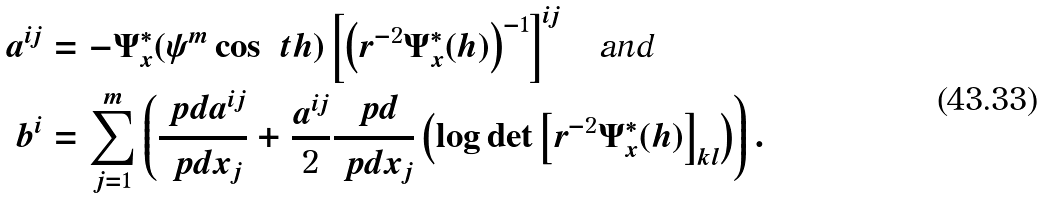Convert formula to latex. <formula><loc_0><loc_0><loc_500><loc_500>a ^ { i j } & = - \Psi _ { x } ^ { * } ( \psi ^ { m } \cos \ t h ) \left [ \left ( r ^ { - 2 } \Psi _ { x } ^ { * } ( h ) \right ) ^ { - 1 } \right ] ^ { i j } \quad \text {and} \\ b ^ { i } & = \sum _ { j = 1 } ^ { m } \left ( \frac { \ p d a ^ { i j } } { \ p d x _ { j } } + \frac { a ^ { i j } } { 2 } \frac { \ p d } { \ p d x _ { j } } \left ( \log \det \left [ r ^ { - 2 } \Psi _ { x } ^ { * } ( h ) \right ] _ { k l } \right ) \right ) .</formula> 